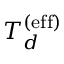<formula> <loc_0><loc_0><loc_500><loc_500>T _ { d } ^ { ( e f f ) }</formula> 